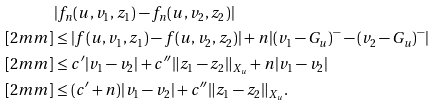Convert formula to latex. <formula><loc_0><loc_0><loc_500><loc_500>& | f _ { n } ( u , v _ { 1 } , z _ { 1 } ) - f _ { n } ( u , v _ { 2 } , z _ { 2 } ) | \\ [ 2 m m ] & \leq | f ( u , v _ { 1 } , z _ { 1 } ) - f ( u , v _ { 2 } , z _ { 2 } ) | + n | ( v _ { 1 } - G _ { u } ) ^ { - } - ( v _ { 2 } - G _ { u } ) ^ { - } | \\ [ 2 m m ] & \leq c ^ { \prime } | v _ { 1 } - v _ { 2 } | + c ^ { \prime \prime } \| z _ { 1 } - z _ { 2 } \| _ { X _ { u } } + n | v _ { 1 } - v _ { 2 } | \\ [ 2 m m ] & \leq ( c ^ { \prime } + n ) | v _ { 1 } - v _ { 2 } | + c ^ { \prime \prime } \| z _ { 1 } - z _ { 2 } \| _ { X _ { u } } .</formula> 